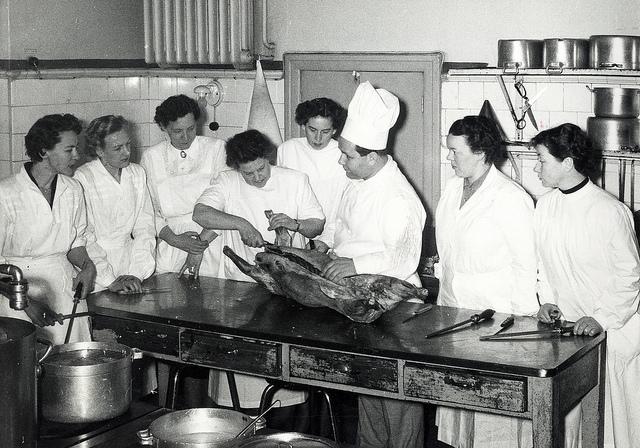Are the people wearing gloves?
Write a very short answer. No. What is on the shelf behind the people?
Be succinct. Pots. What are the women doing?
Short answer required. Watching. Are the chefs cooking?
Keep it brief. Yes. 